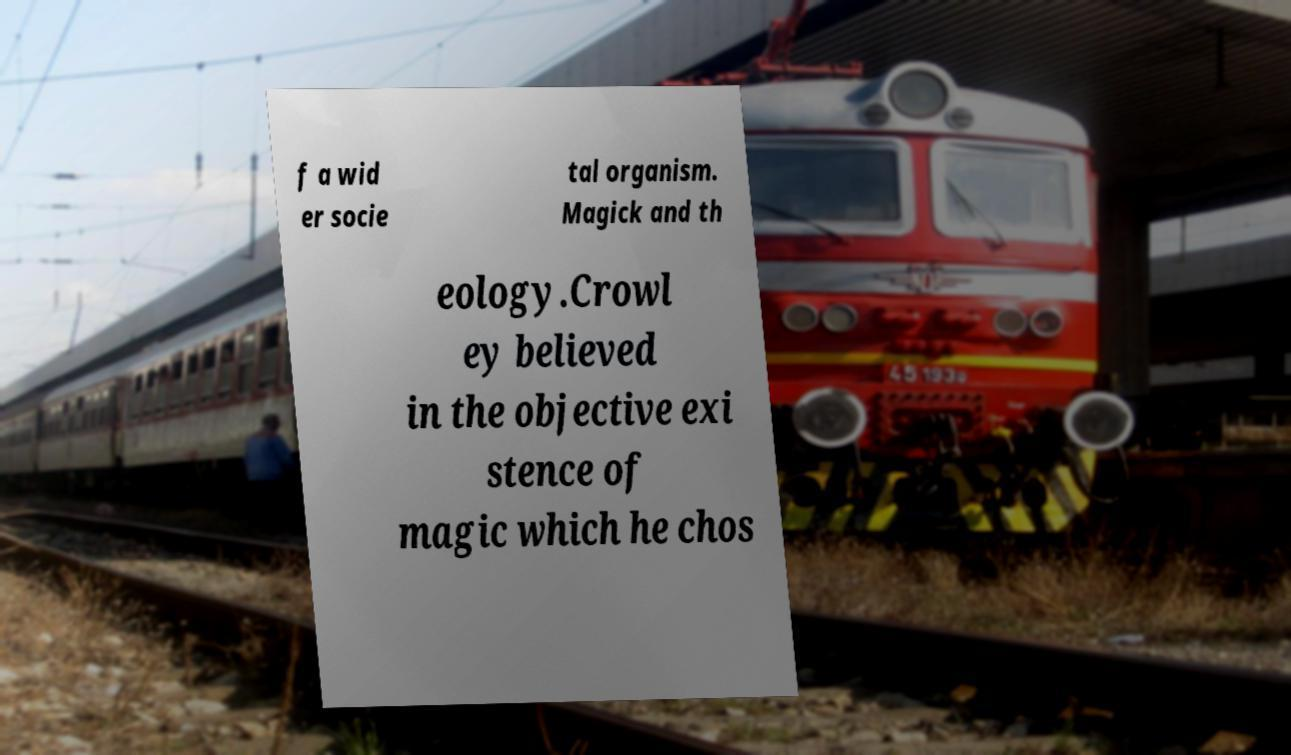Could you assist in decoding the text presented in this image and type it out clearly? f a wid er socie tal organism. Magick and th eology.Crowl ey believed in the objective exi stence of magic which he chos 